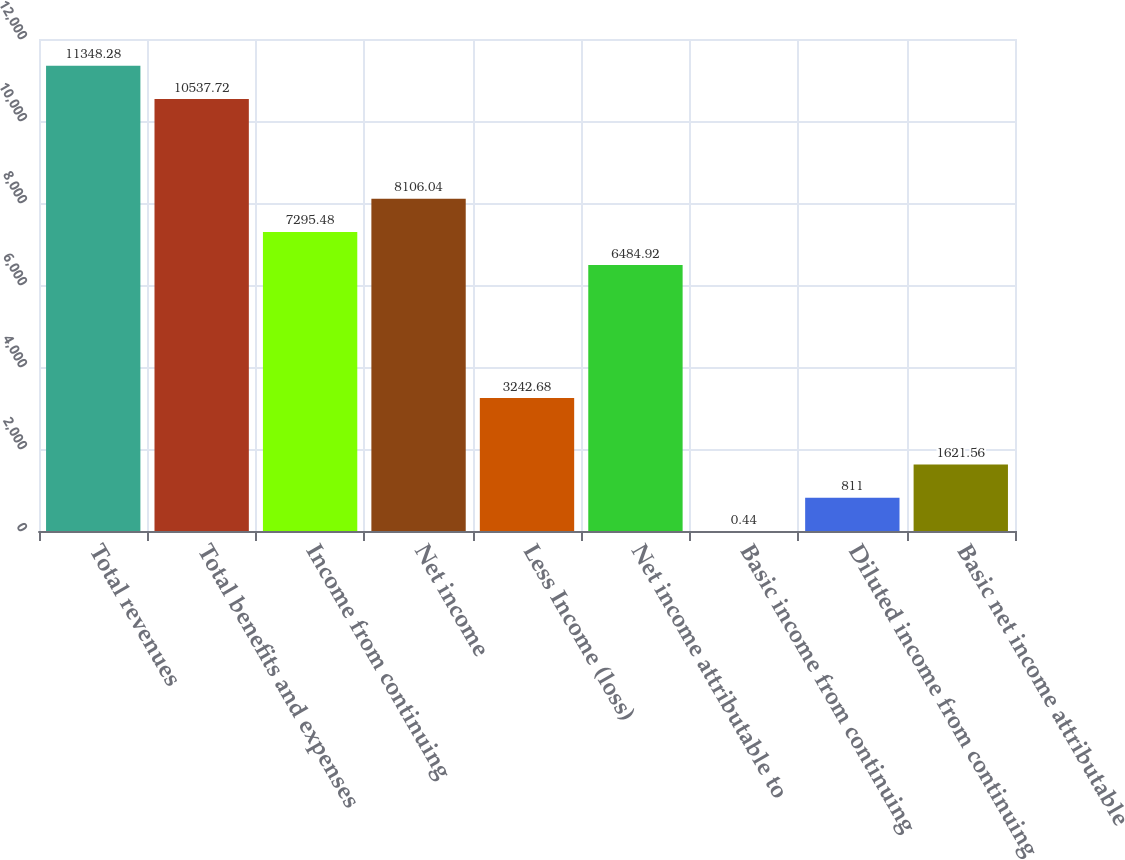Convert chart. <chart><loc_0><loc_0><loc_500><loc_500><bar_chart><fcel>Total revenues<fcel>Total benefits and expenses<fcel>Income from continuing<fcel>Net income<fcel>Less Income (loss)<fcel>Net income attributable to<fcel>Basic income from continuing<fcel>Diluted income from continuing<fcel>Basic net income attributable<nl><fcel>11348.3<fcel>10537.7<fcel>7295.48<fcel>8106.04<fcel>3242.68<fcel>6484.92<fcel>0.44<fcel>811<fcel>1621.56<nl></chart> 